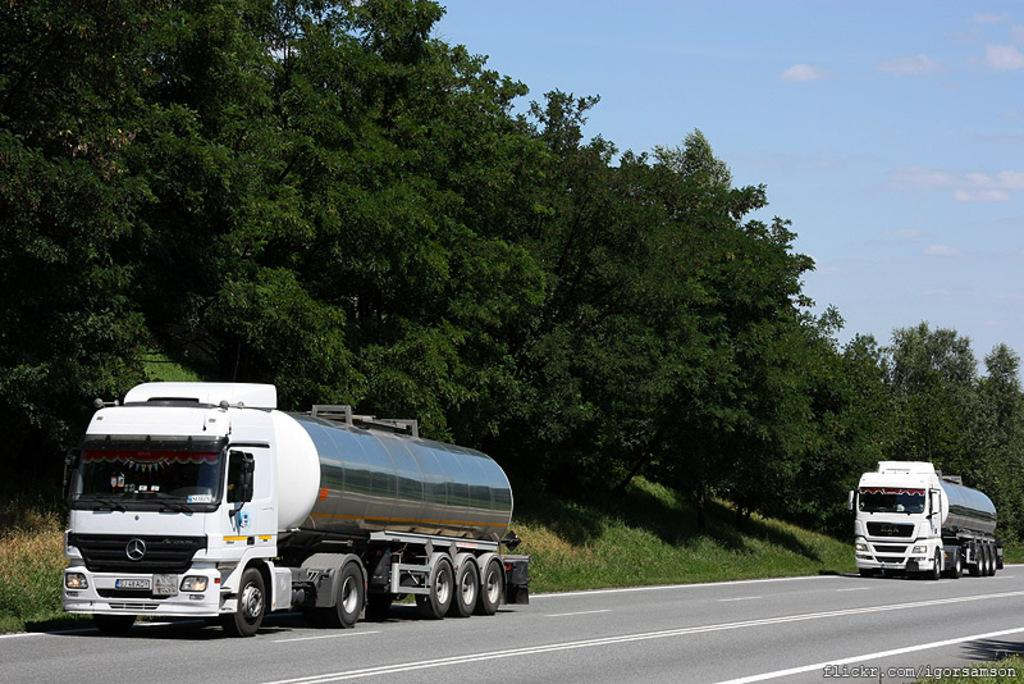What vehicles can be seen on the road in the image? There are two trucks on the road in the image. What else is visible in the image besides the trucks? There is a text visible in the image, as well as grass, trees, and the sky in the background. What time of day was the image taken? The image was taken during the day. What type of tramp can be seen jumping in the image? There is no tramp present in the image; it features two trucks on the road and a background with grass, trees, and the sky. What is the condition of the space station in the image? There is no space station present in the image; it is a photograph taken on Earth. 